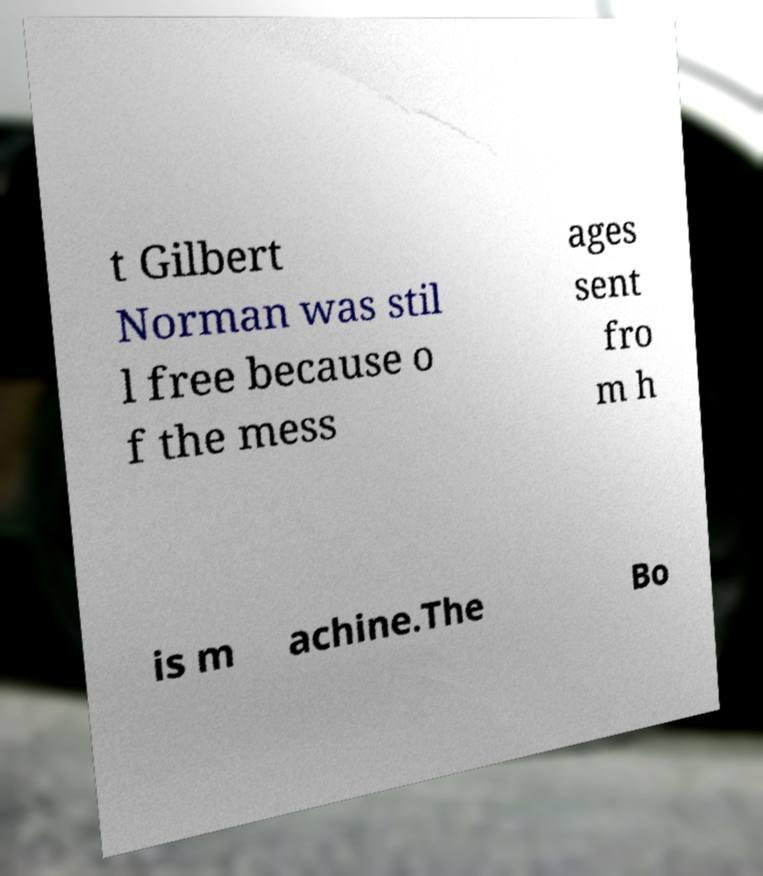What messages or text are displayed in this image? I need them in a readable, typed format. t Gilbert Norman was stil l free because o f the mess ages sent fro m h is m achine.The Bo 